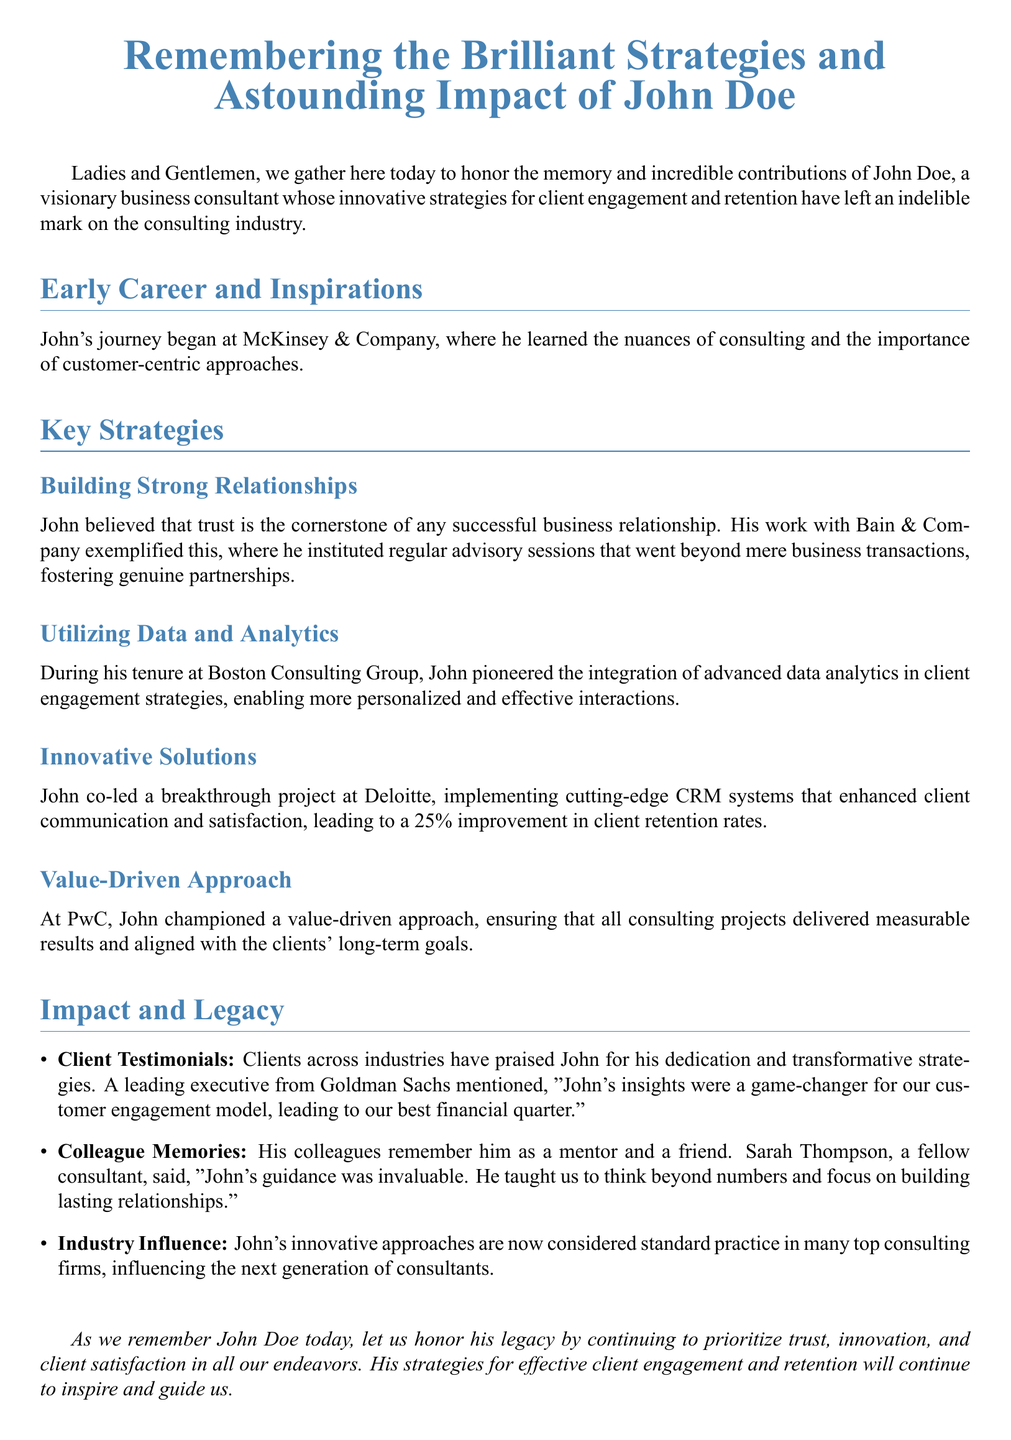What company did John start his career at? The document states that John's journey began at McKinsey & Company.
Answer: McKinsey & Company What significant project did John co-lead at Deloitte? The document mentions that John co-led a project implementing cutting-edge CRM systems at Deloitte.
Answer: Cutting-edge CRM systems What improvement in client retention rates did John's project at Deloitte achieve? The document indicates that the project led to a 25% improvement in client retention rates.
Answer: 25% What approach did John champion at PwC? The document describes that John championed a value-driven approach at PwC.
Answer: Value-driven approach Who described John’s insights as a game-changer? The document quotes a leading executive from Goldman Sachs saying "John's insights were a game-changer."
Answer: Goldman Sachs What was highlighted as the cornerstone of successful business relationships according to John? The document states that John believed trust is the cornerstone of any successful business relationship.
Answer: Trust What did Sarah Thompson refer to John as? The document notes that Sarah Thompson referred to John as a mentor and a friend.
Answer: Mentor and friend What is considered standard practice in top consulting firms today? The document mentions that John's innovative approaches are now considered standard practice.
Answer: Innovative approaches 